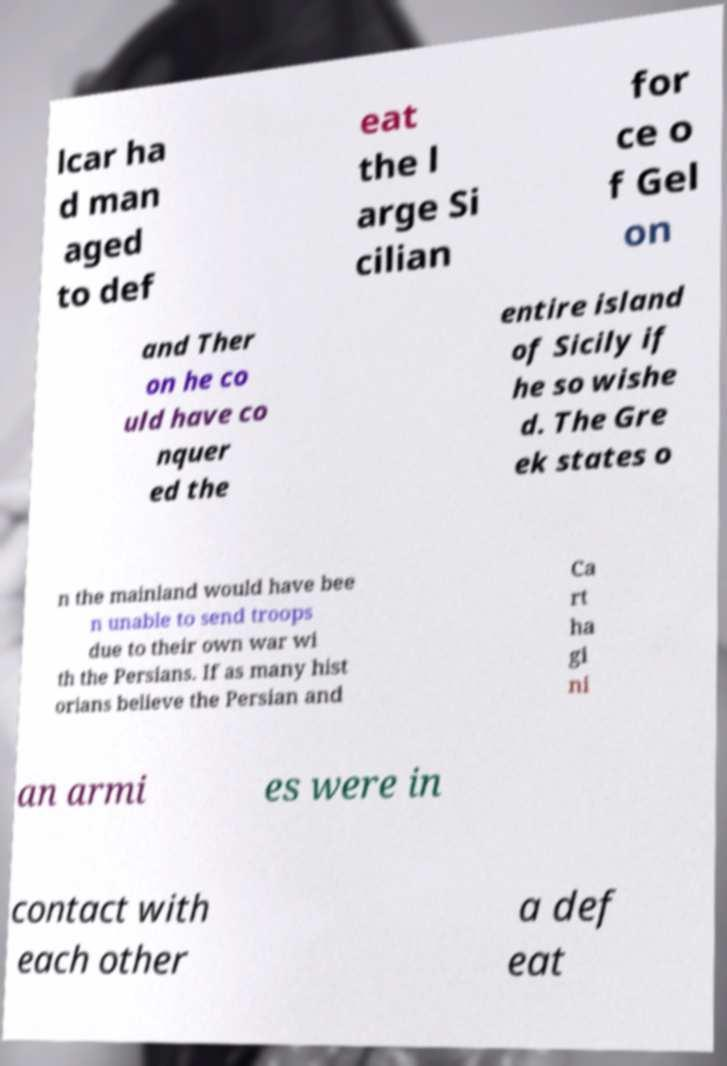I need the written content from this picture converted into text. Can you do that? lcar ha d man aged to def eat the l arge Si cilian for ce o f Gel on and Ther on he co uld have co nquer ed the entire island of Sicily if he so wishe d. The Gre ek states o n the mainland would have bee n unable to send troops due to their own war wi th the Persians. If as many hist orians believe the Persian and Ca rt ha gi ni an armi es were in contact with each other a def eat 